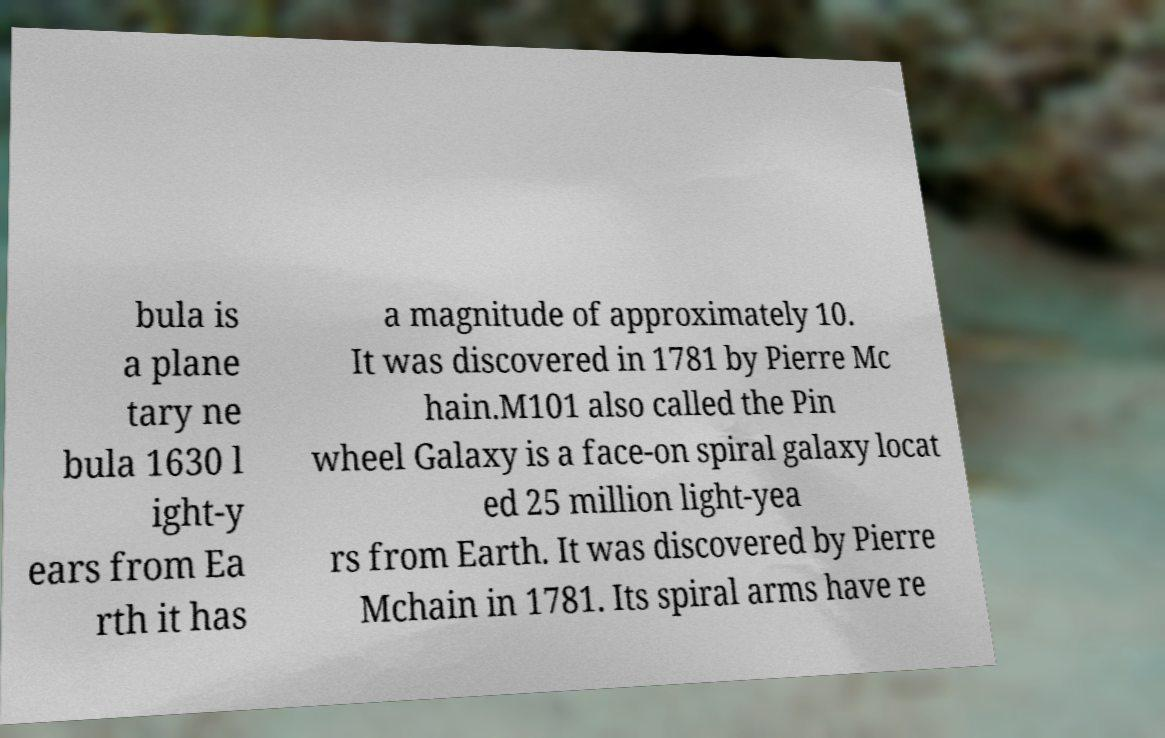For documentation purposes, I need the text within this image transcribed. Could you provide that? bula is a plane tary ne bula 1630 l ight-y ears from Ea rth it has a magnitude of approximately 10. It was discovered in 1781 by Pierre Mc hain.M101 also called the Pin wheel Galaxy is a face-on spiral galaxy locat ed 25 million light-yea rs from Earth. It was discovered by Pierre Mchain in 1781. Its spiral arms have re 